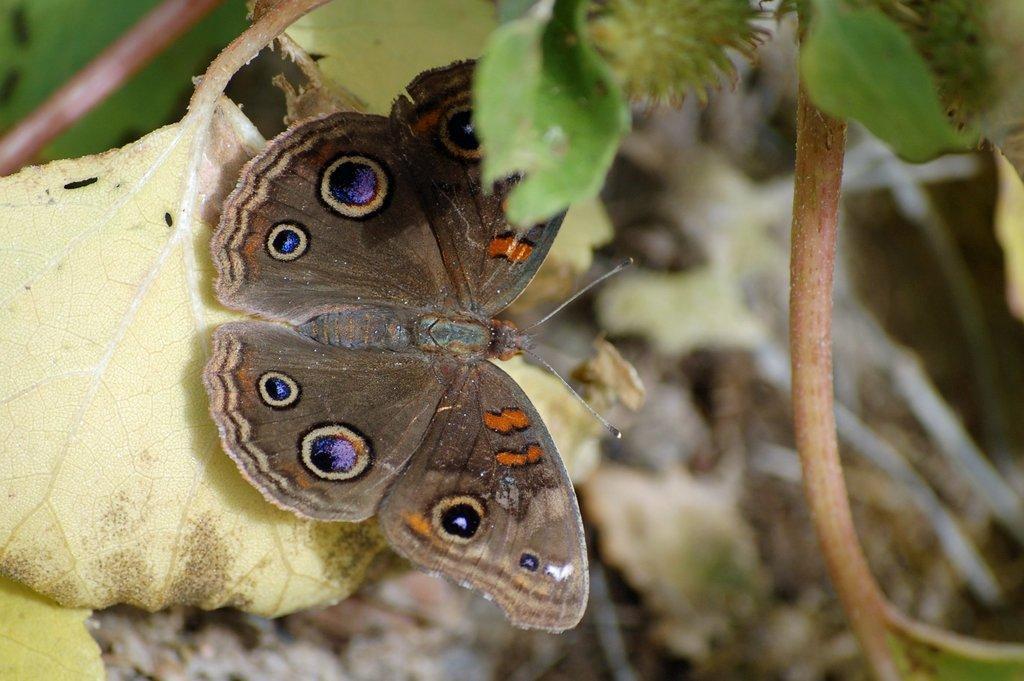How would you summarize this image in a sentence or two? In the picture I can see a butterfly on a leaf. The background of the image is blurred. 